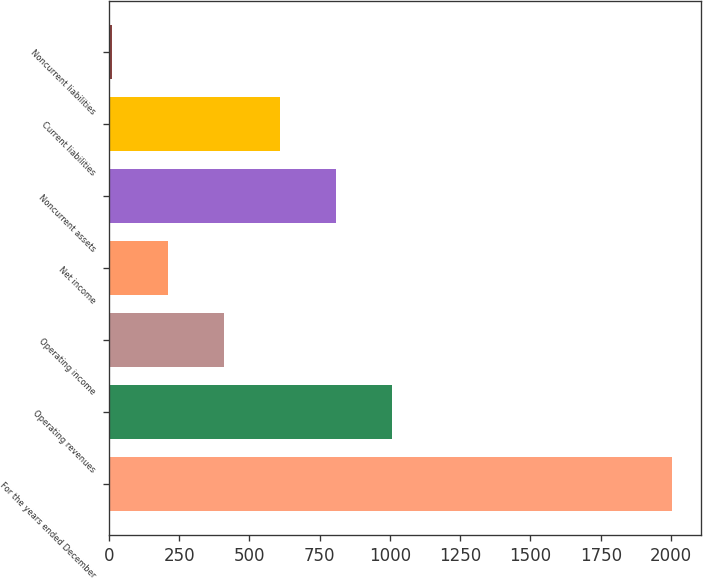Convert chart. <chart><loc_0><loc_0><loc_500><loc_500><bar_chart><fcel>For the years ended December<fcel>Operating revenues<fcel>Operating income<fcel>Net income<fcel>Noncurrent assets<fcel>Current liabilities<fcel>Noncurrent liabilities<nl><fcel>2005<fcel>1008<fcel>409.8<fcel>210.4<fcel>808.6<fcel>609.2<fcel>11<nl></chart> 